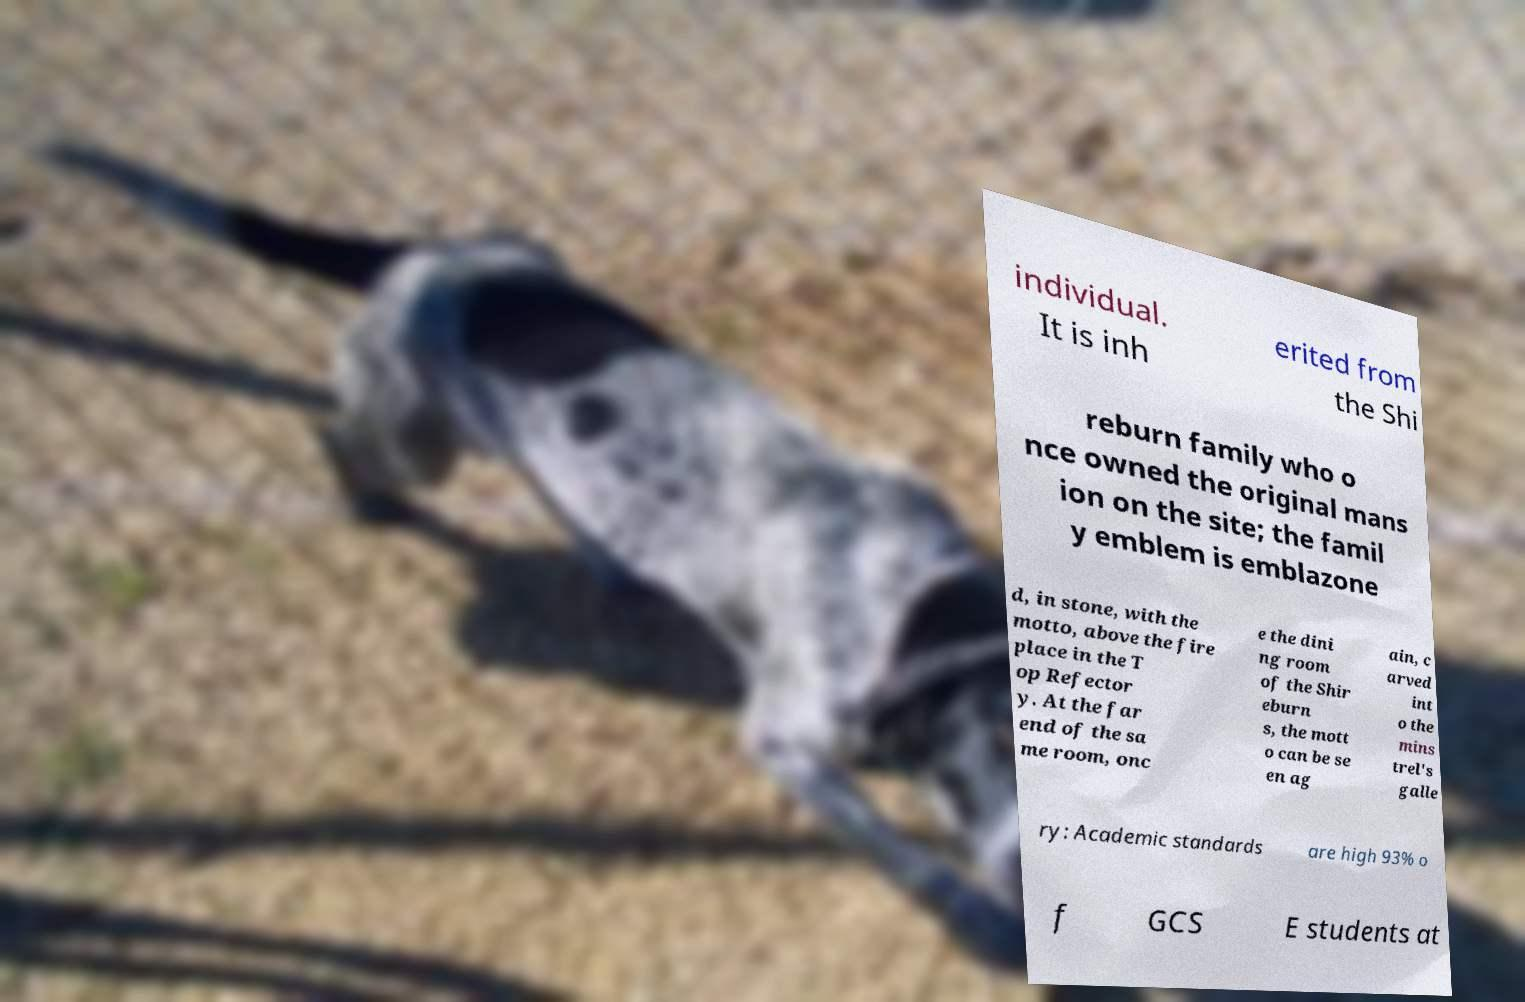What messages or text are displayed in this image? I need them in a readable, typed format. individual. It is inh erited from the Shi reburn family who o nce owned the original mans ion on the site; the famil y emblem is emblazone d, in stone, with the motto, above the fire place in the T op Refector y. At the far end of the sa me room, onc e the dini ng room of the Shir eburn s, the mott o can be se en ag ain, c arved int o the mins trel's galle ry: Academic standards are high 93% o f GCS E students at 